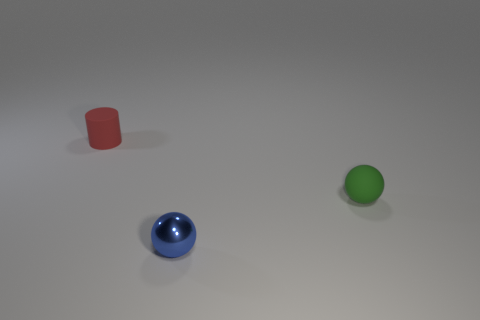How many other green matte spheres are the same size as the green rubber sphere? 0 